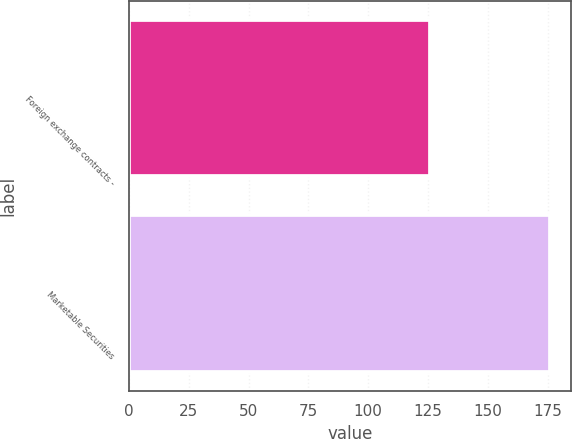<chart> <loc_0><loc_0><loc_500><loc_500><bar_chart><fcel>Foreign exchange contracts -<fcel>Marketable Securities<nl><fcel>126<fcel>176<nl></chart> 